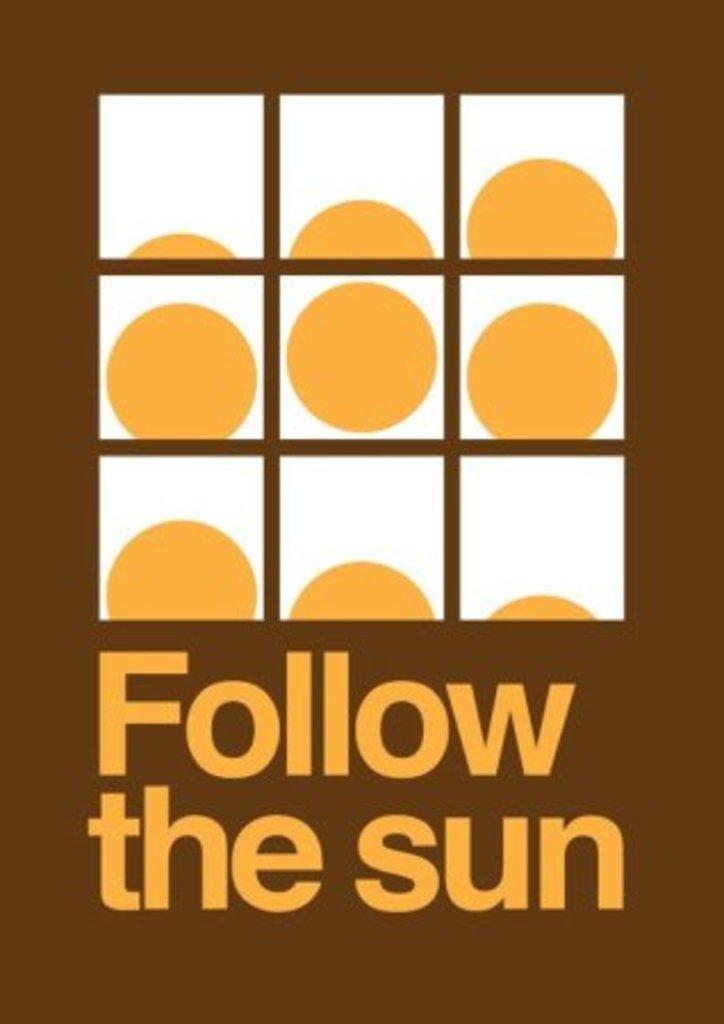What is featured in the image? There is a poster in the image. What can be found on the poster? The poster contains words. Can you describe the design of the poster? There are round shapes in square boxes on the poster. How does the poster express disgust in the image? The poster does not express disgust in the image; it only contains words and round shapes in square boxes. 